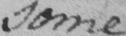Can you tell me what this handwritten text says? some 